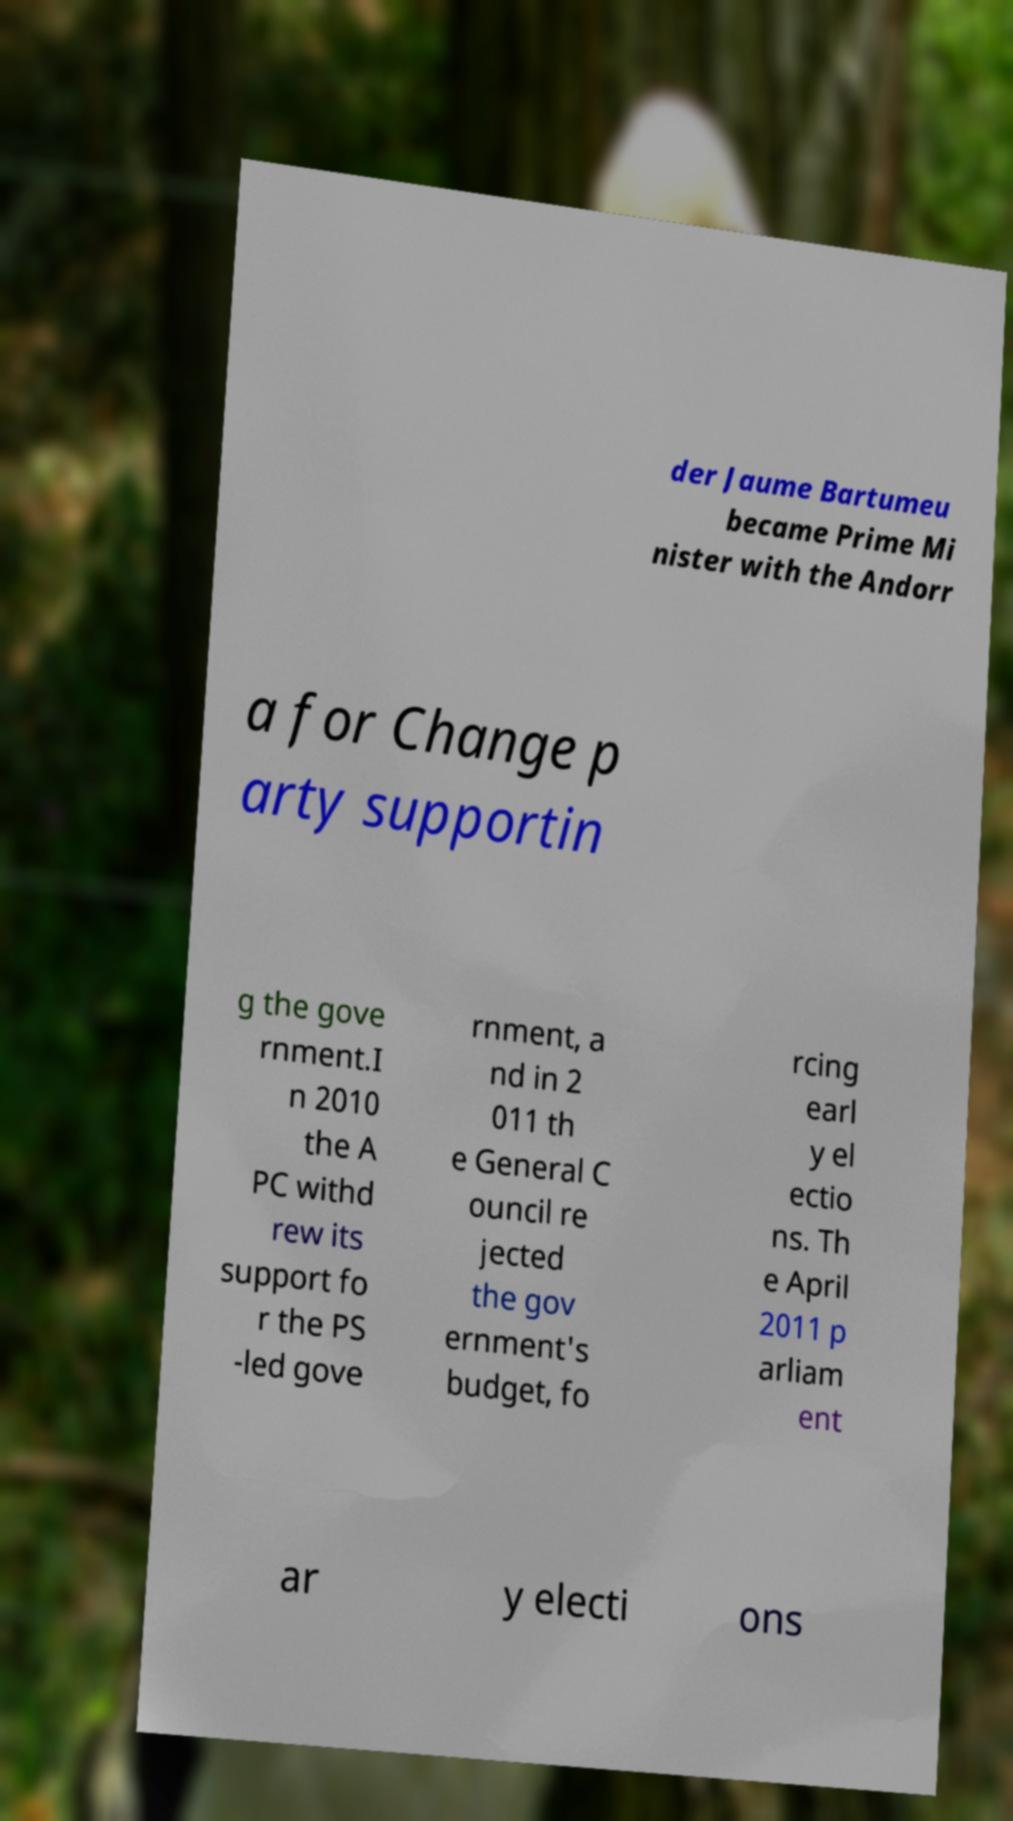Can you accurately transcribe the text from the provided image for me? der Jaume Bartumeu became Prime Mi nister with the Andorr a for Change p arty supportin g the gove rnment.I n 2010 the A PC withd rew its support fo r the PS -led gove rnment, a nd in 2 011 th e General C ouncil re jected the gov ernment's budget, fo rcing earl y el ectio ns. Th e April 2011 p arliam ent ar y electi ons 